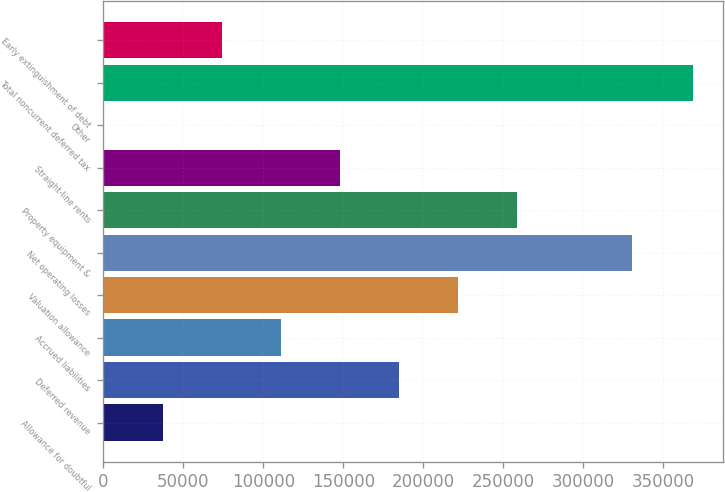Convert chart to OTSL. <chart><loc_0><loc_0><loc_500><loc_500><bar_chart><fcel>Allowance for doubtful<fcel>Deferred revenue<fcel>Accrued liabilities<fcel>Valuation allowance<fcel>Net operating losses<fcel>Property equipment &<fcel>Straight-line rents<fcel>Other<fcel>Total noncurrent deferred tax<fcel>Early extinguishment of debt<nl><fcel>37222.7<fcel>184610<fcel>110916<fcel>221456<fcel>330187<fcel>258303<fcel>147763<fcel>376<fcel>368843<fcel>74069.4<nl></chart> 